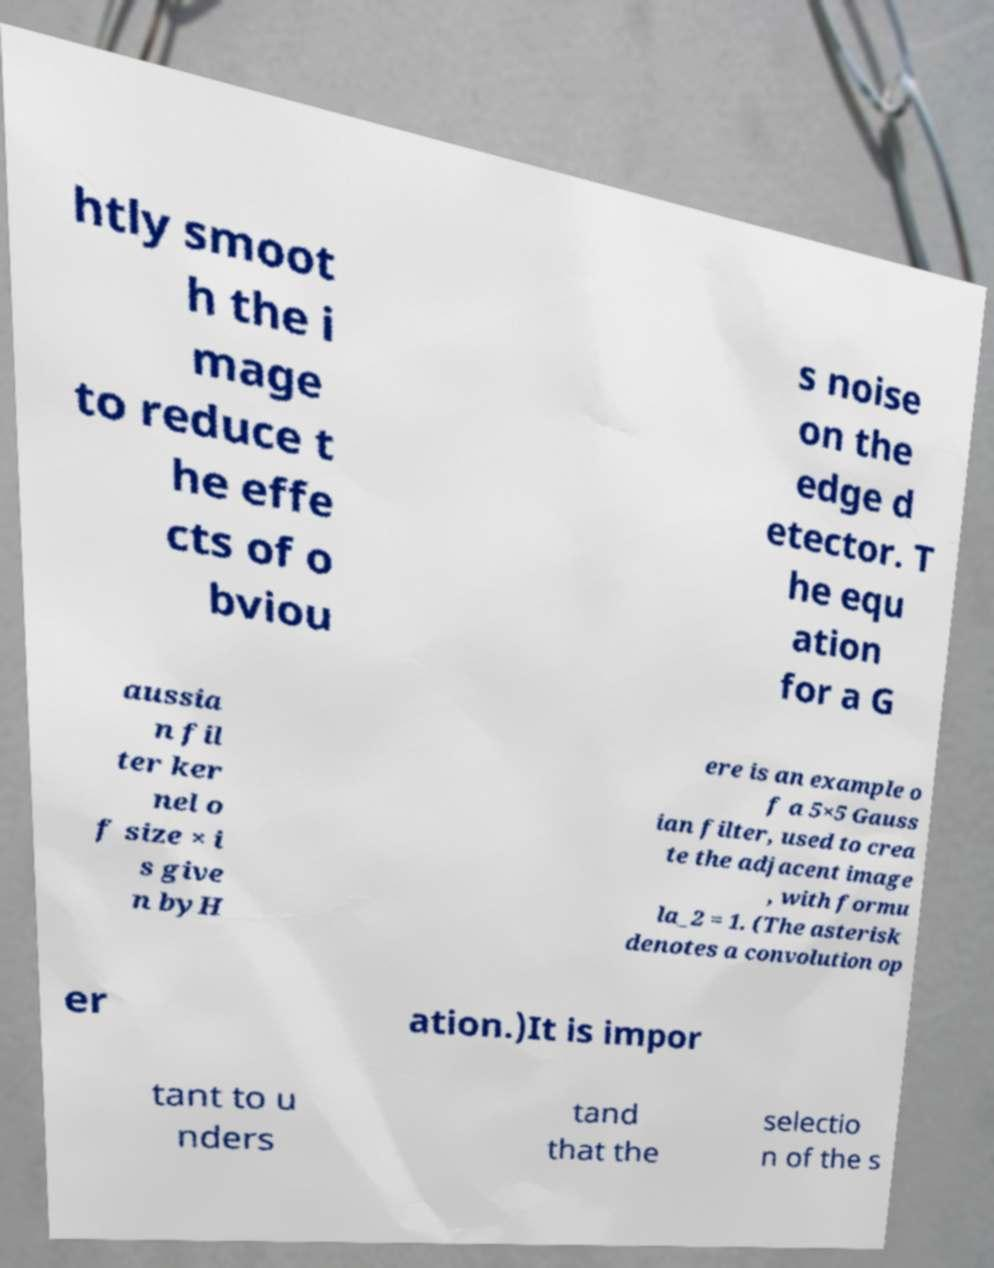What messages or text are displayed in this image? I need them in a readable, typed format. htly smoot h the i mage to reduce t he effe cts of o bviou s noise on the edge d etector. T he equ ation for a G aussia n fil ter ker nel o f size × i s give n byH ere is an example o f a 5×5 Gauss ian filter, used to crea te the adjacent image , with formu la_2 = 1. (The asterisk denotes a convolution op er ation.)It is impor tant to u nders tand that the selectio n of the s 